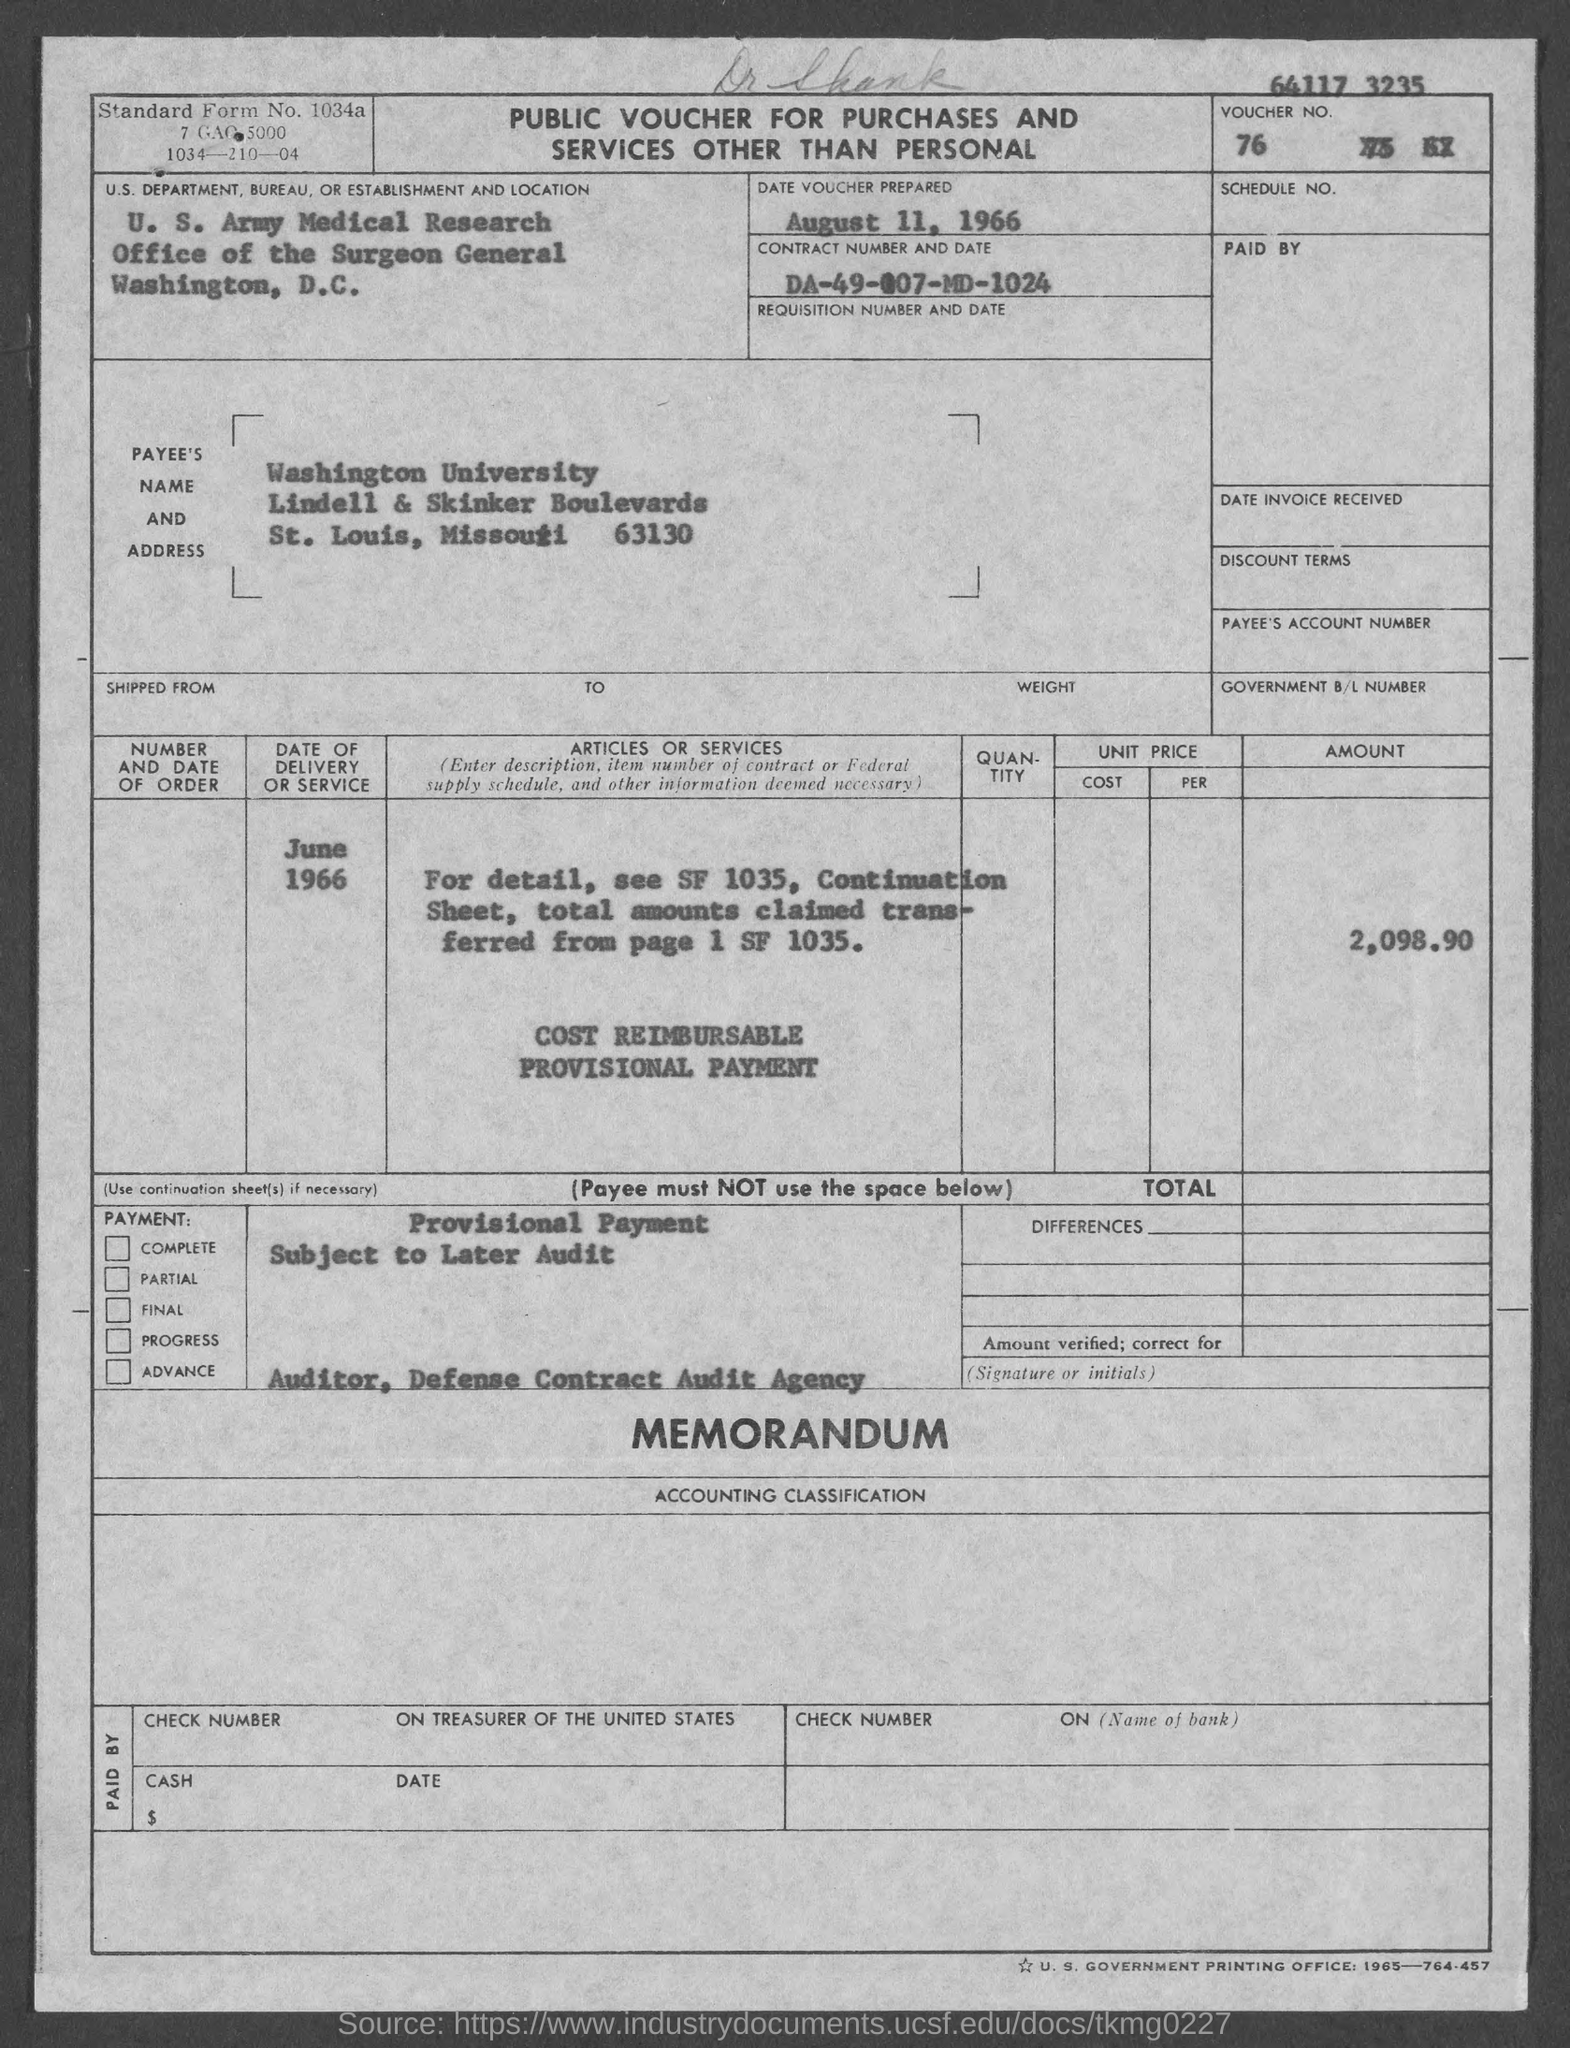Identify some key points in this picture. The contract number and date are DA-49-007-MD-1024. The amount is 2,098.90. The date of delivery or service was June 1966. The date voucher was prepared on August 11, 1966. 